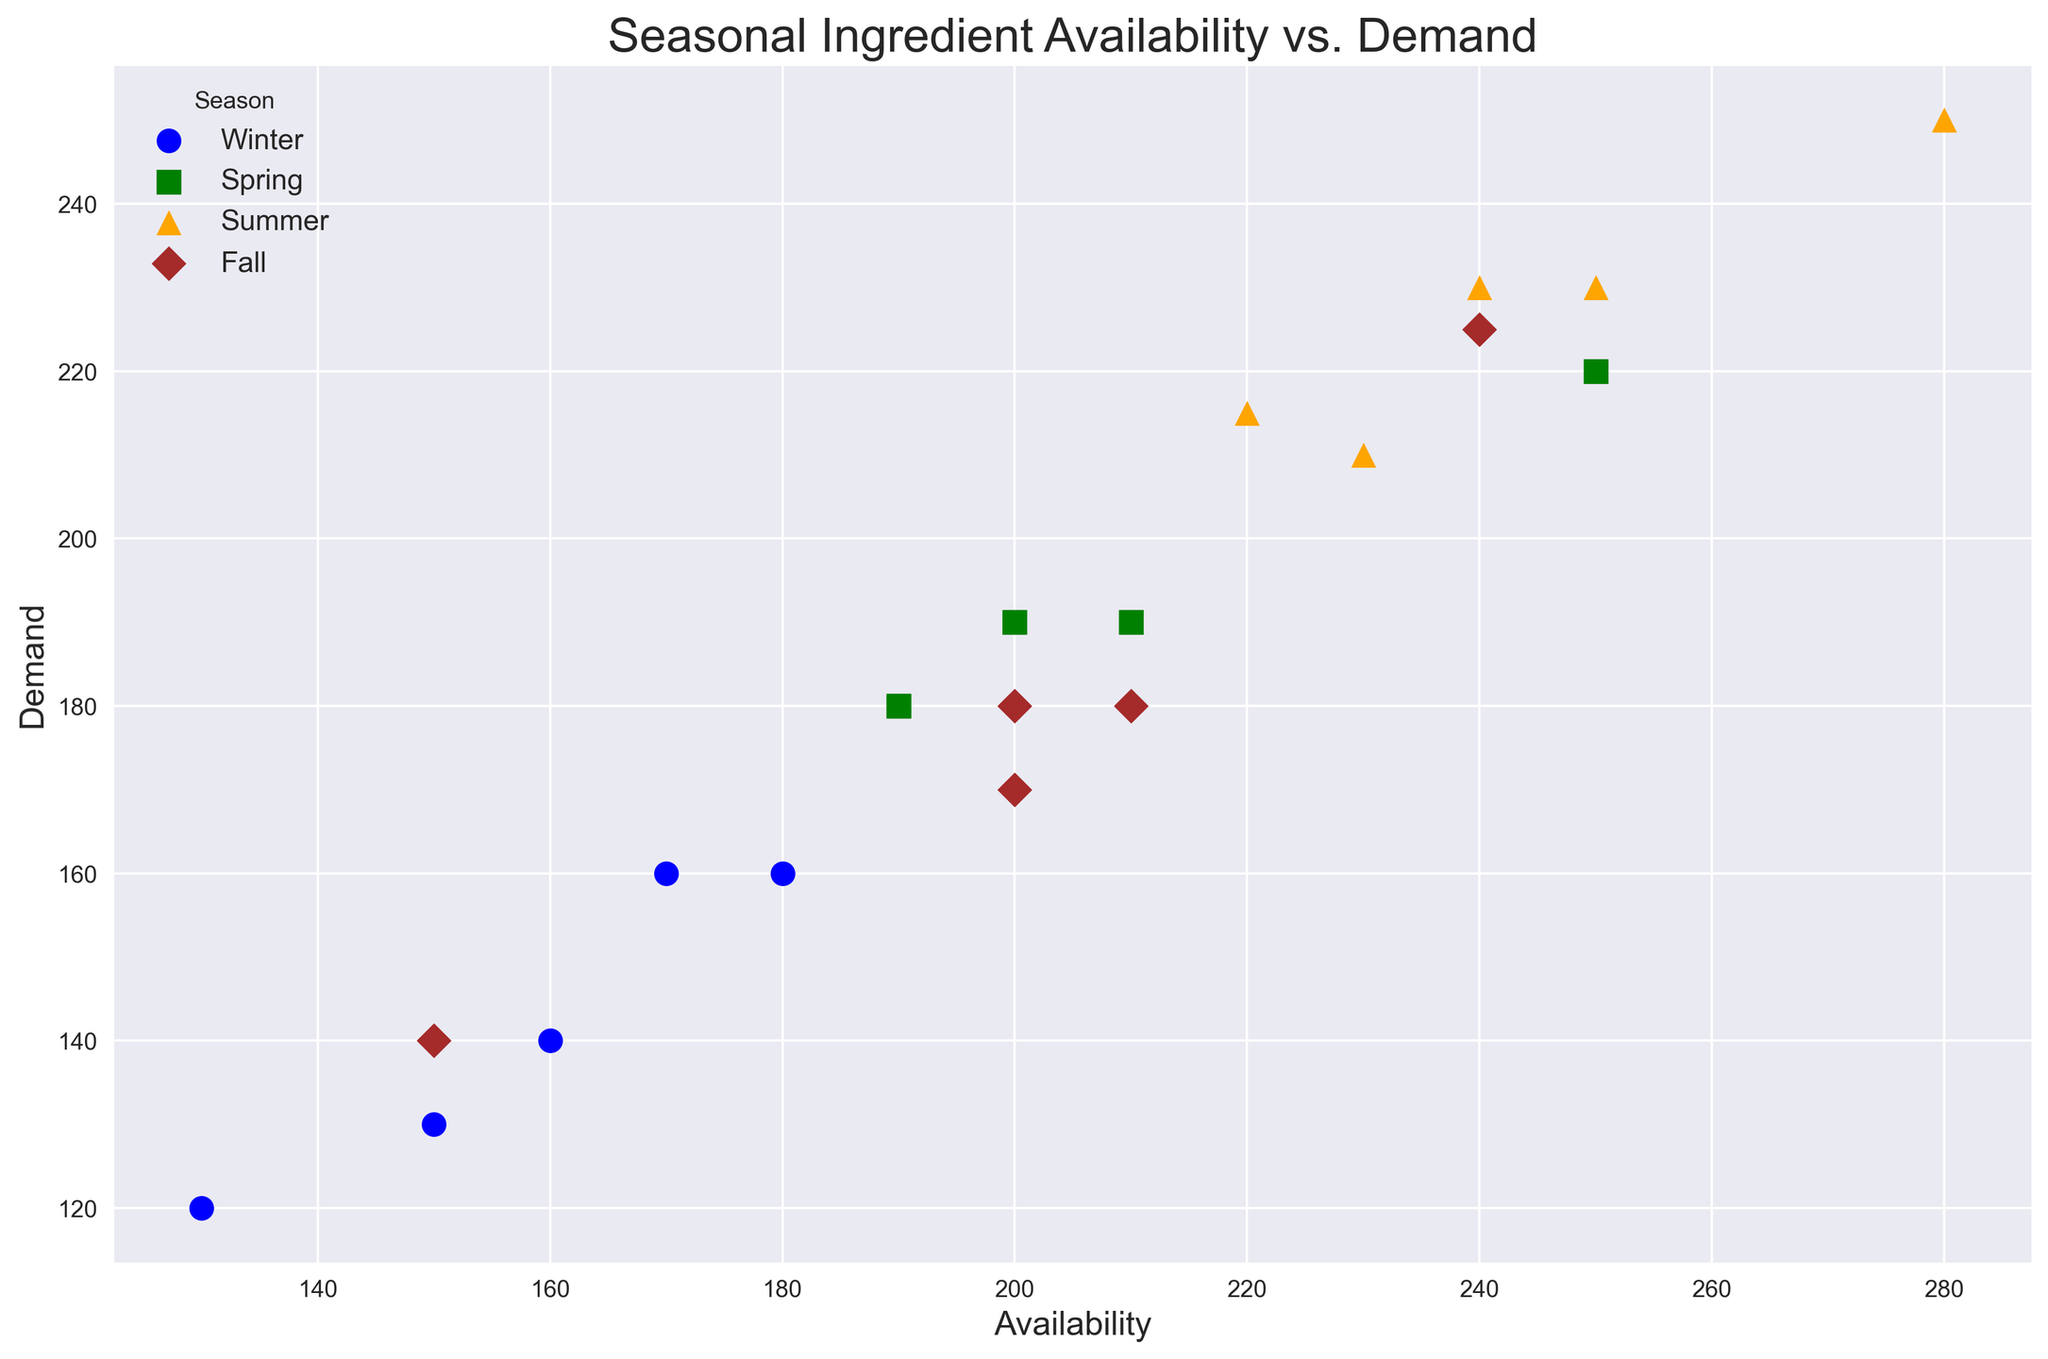What's the season with the highest demand for an ingredient? To find the season with the highest demand for an ingredient, look at the y-axis values, which represent demand, and identify the highest point in the scatter plot. Check the color or marker shape that indicates the season and refer to the legend for the corresponding season.
Answer: Summer (Corn, Demand = 250) Which season has the most number of unique ingredients? Count the number of unique markers for each season as indicated by the legend. Compare these counts to determine which season has the most unique markers.
Answer: Summer Are there any ingredients with equal availability and demand? Look for points on the scatter plot where the x-axis (Availability) and y-axis (Demand) values are equal. Verify these points by cross-referencing both values.
Answer: No What is the average availability of ingredients in Fall? Locate all Fall ingredients based on the shapes/colors for that season. Sum the x-axis values (Availability) and divide by the number of Fall ingredients. Fall ingredients are Apples, Pumpkins, Squashes, Brussels Sprouts, and Pears. Availability values are (240, 210, 200, 150, 200). Sum = 1000, Number = 5.
Answer: 200 By how much does the demand for Summer Tropical Fruits exceed the demand for Winter Broccoli? Locate the points for Tropical Fruits and Broccoli using their respective markers/colors. Subtract the y-axis (Demand) value of Winter Broccoli from the y-axis value of Summer Tropical Fruits. Demand for Tropical Fruits is 215 and for Broccoli is 140. 215 - 140 = 75.
Answer: 75 Which ingredient in Spring has the highest availability, and what is its demand? Find the color/marker corresponding to Spring. Identify the point with the highest x-axis (Availability) value among all Spring points and note the corresponding y-axis (Demand) value.
Answer: Berries, Demand = 220 Is the demand for Winter Citrus Fruits higher than the demand for Fall Pumpkins? Compare the y-axis values (Demand) for Citrus Fruits and Pumpkins. Citrus Fruits' demand is 160, and Pumpkins' demand is 180.
Answer: No What is the median demand for ingredients in Winter? List all y-axis values (Demand) for Winter markers, sort them, and find the middle value. Demand in Winter are 130, 160, 140, 120, and 160. Sorted demands: 120, 130, 140, 160, 160. Median is the middle value: 140.
Answer: 140 